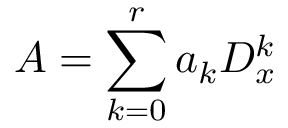Convert formula to latex. <formula><loc_0><loc_0><loc_500><loc_500>A = \sum _ { k = 0 } ^ { r } a _ { k } D _ { x } ^ { k }</formula> 